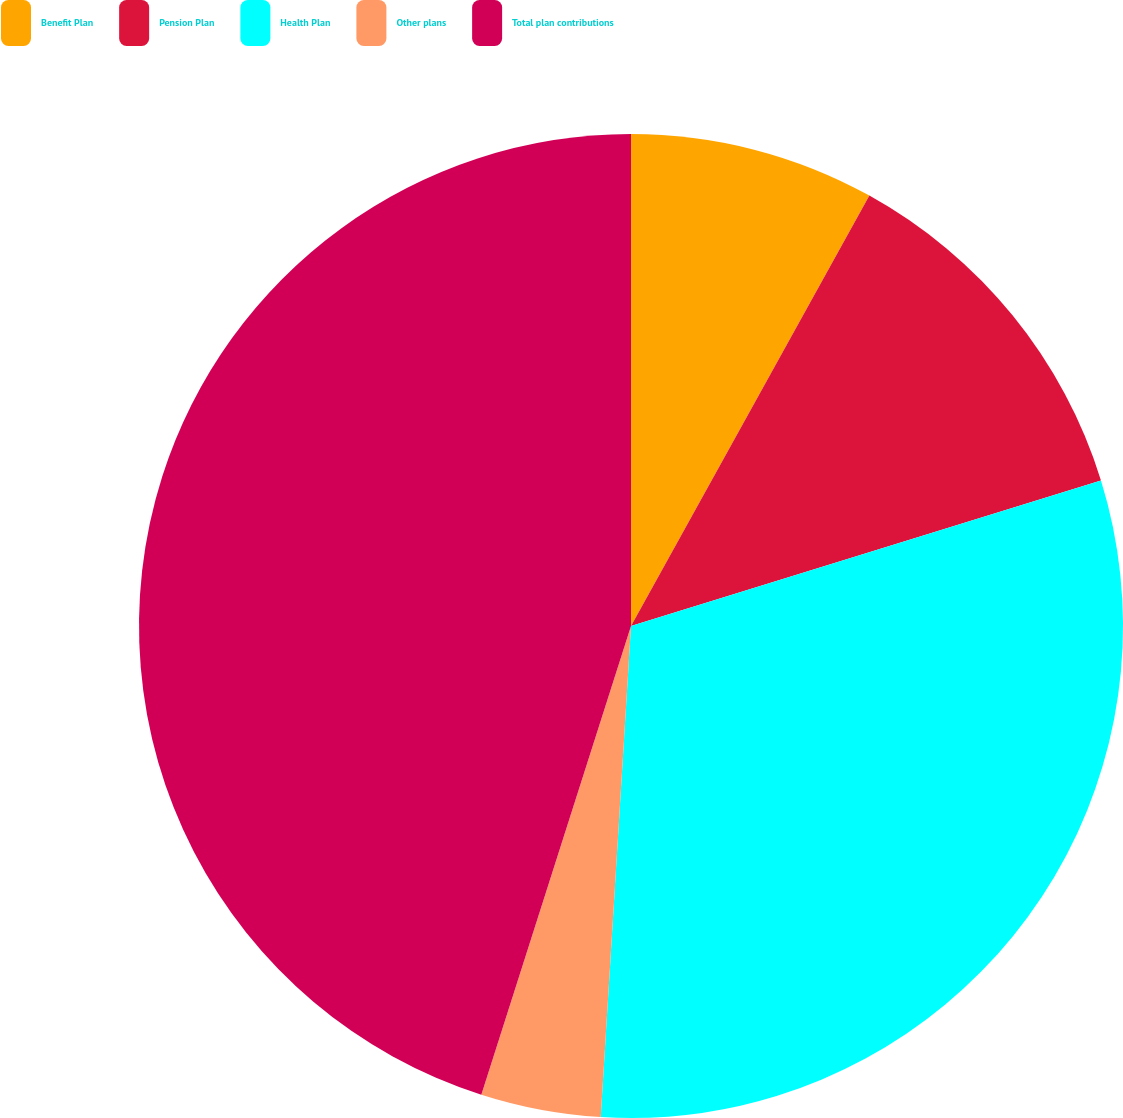Convert chart to OTSL. <chart><loc_0><loc_0><loc_500><loc_500><pie_chart><fcel>Benefit Plan<fcel>Pension Plan<fcel>Health Plan<fcel>Other plans<fcel>Total plan contributions<nl><fcel>8.05%<fcel>12.17%<fcel>30.76%<fcel>3.94%<fcel>45.08%<nl></chart> 